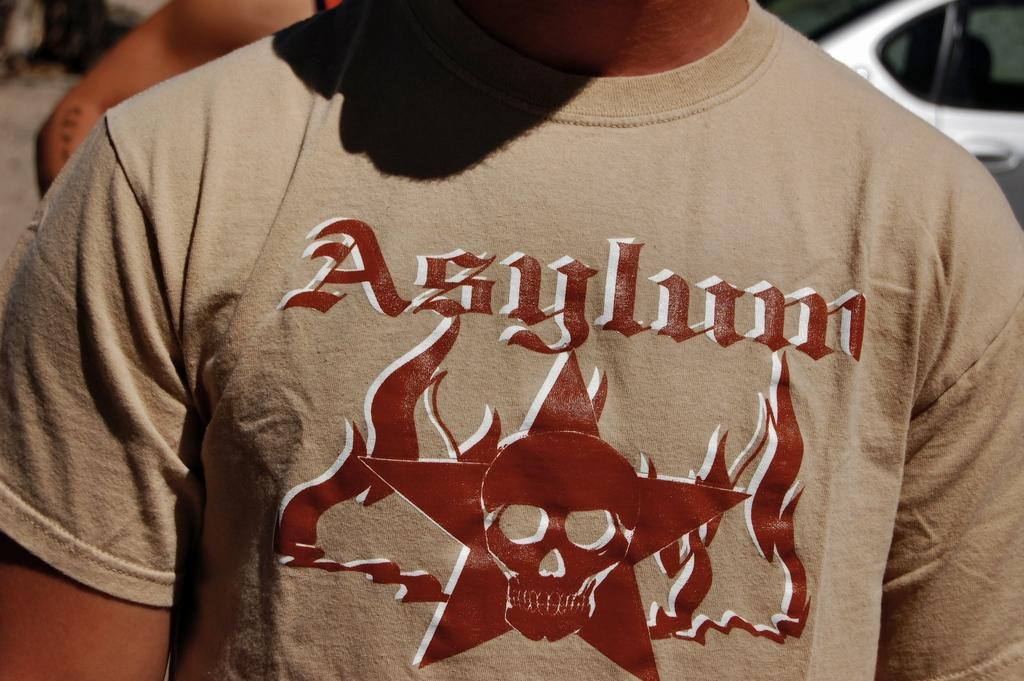Provide a one-sentence caption for the provided image. A tshirt with a skull and the word Asylum on it. 